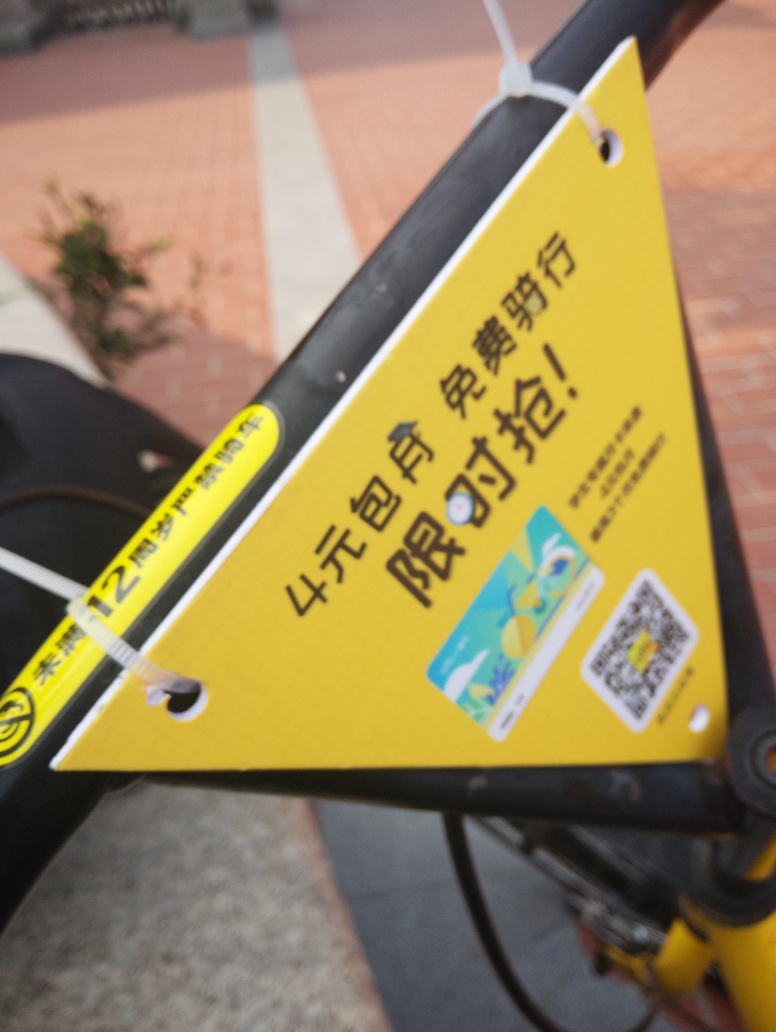Is there any loss of texture details in the image? There is a noticeable loss of texture details in the image due to blur, which obscures finer textures and elements, especially those present in the background and on the edges of the yellow card. This is likely caused by either motion during the capture of the photo or a shallow depth of field, which causes elements outside the focal plane to appear blurry. 